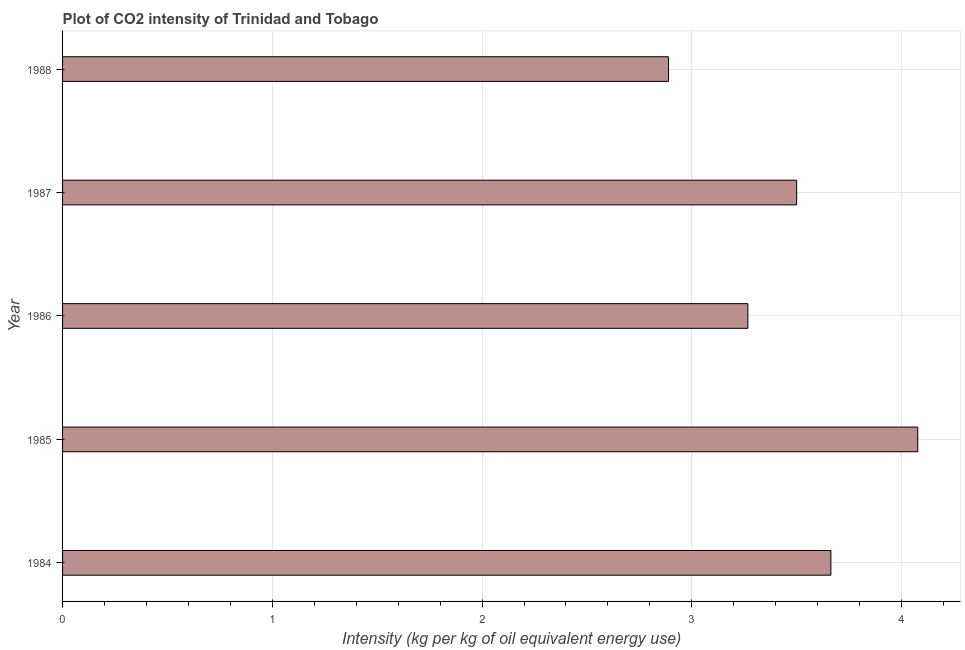What is the title of the graph?
Give a very brief answer. Plot of CO2 intensity of Trinidad and Tobago. What is the label or title of the X-axis?
Keep it short and to the point. Intensity (kg per kg of oil equivalent energy use). What is the co2 intensity in 1987?
Give a very brief answer. 3.5. Across all years, what is the maximum co2 intensity?
Offer a terse response. 4.08. Across all years, what is the minimum co2 intensity?
Your answer should be very brief. 2.89. In which year was the co2 intensity minimum?
Keep it short and to the point. 1988. What is the sum of the co2 intensity?
Your answer should be very brief. 17.4. What is the difference between the co2 intensity in 1987 and 1988?
Offer a very short reply. 0.61. What is the average co2 intensity per year?
Ensure brevity in your answer.  3.48. What is the median co2 intensity?
Your response must be concise. 3.5. Do a majority of the years between 1984 and 1988 (inclusive) have co2 intensity greater than 2.2 kg?
Your answer should be compact. Yes. What is the ratio of the co2 intensity in 1985 to that in 1988?
Keep it short and to the point. 1.41. Is the difference between the co2 intensity in 1984 and 1988 greater than the difference between any two years?
Offer a very short reply. No. What is the difference between the highest and the second highest co2 intensity?
Give a very brief answer. 0.41. What is the difference between the highest and the lowest co2 intensity?
Keep it short and to the point. 1.19. How many bars are there?
Ensure brevity in your answer.  5. Are all the bars in the graph horizontal?
Offer a terse response. Yes. How many years are there in the graph?
Make the answer very short. 5. What is the difference between two consecutive major ticks on the X-axis?
Make the answer very short. 1. What is the Intensity (kg per kg of oil equivalent energy use) in 1984?
Provide a short and direct response. 3.66. What is the Intensity (kg per kg of oil equivalent energy use) of 1985?
Ensure brevity in your answer.  4.08. What is the Intensity (kg per kg of oil equivalent energy use) of 1986?
Keep it short and to the point. 3.27. What is the Intensity (kg per kg of oil equivalent energy use) of 1987?
Ensure brevity in your answer.  3.5. What is the Intensity (kg per kg of oil equivalent energy use) of 1988?
Your answer should be compact. 2.89. What is the difference between the Intensity (kg per kg of oil equivalent energy use) in 1984 and 1985?
Keep it short and to the point. -0.41. What is the difference between the Intensity (kg per kg of oil equivalent energy use) in 1984 and 1986?
Provide a short and direct response. 0.4. What is the difference between the Intensity (kg per kg of oil equivalent energy use) in 1984 and 1987?
Give a very brief answer. 0.16. What is the difference between the Intensity (kg per kg of oil equivalent energy use) in 1984 and 1988?
Offer a very short reply. 0.77. What is the difference between the Intensity (kg per kg of oil equivalent energy use) in 1985 and 1986?
Offer a very short reply. 0.81. What is the difference between the Intensity (kg per kg of oil equivalent energy use) in 1985 and 1987?
Provide a succinct answer. 0.58. What is the difference between the Intensity (kg per kg of oil equivalent energy use) in 1985 and 1988?
Your response must be concise. 1.19. What is the difference between the Intensity (kg per kg of oil equivalent energy use) in 1986 and 1987?
Give a very brief answer. -0.23. What is the difference between the Intensity (kg per kg of oil equivalent energy use) in 1986 and 1988?
Offer a terse response. 0.38. What is the difference between the Intensity (kg per kg of oil equivalent energy use) in 1987 and 1988?
Make the answer very short. 0.61. What is the ratio of the Intensity (kg per kg of oil equivalent energy use) in 1984 to that in 1985?
Your response must be concise. 0.9. What is the ratio of the Intensity (kg per kg of oil equivalent energy use) in 1984 to that in 1986?
Keep it short and to the point. 1.12. What is the ratio of the Intensity (kg per kg of oil equivalent energy use) in 1984 to that in 1987?
Provide a succinct answer. 1.05. What is the ratio of the Intensity (kg per kg of oil equivalent energy use) in 1984 to that in 1988?
Provide a short and direct response. 1.27. What is the ratio of the Intensity (kg per kg of oil equivalent energy use) in 1985 to that in 1986?
Your answer should be very brief. 1.25. What is the ratio of the Intensity (kg per kg of oil equivalent energy use) in 1985 to that in 1987?
Ensure brevity in your answer.  1.17. What is the ratio of the Intensity (kg per kg of oil equivalent energy use) in 1985 to that in 1988?
Provide a short and direct response. 1.41. What is the ratio of the Intensity (kg per kg of oil equivalent energy use) in 1986 to that in 1987?
Make the answer very short. 0.93. What is the ratio of the Intensity (kg per kg of oil equivalent energy use) in 1986 to that in 1988?
Your answer should be very brief. 1.13. What is the ratio of the Intensity (kg per kg of oil equivalent energy use) in 1987 to that in 1988?
Give a very brief answer. 1.21. 